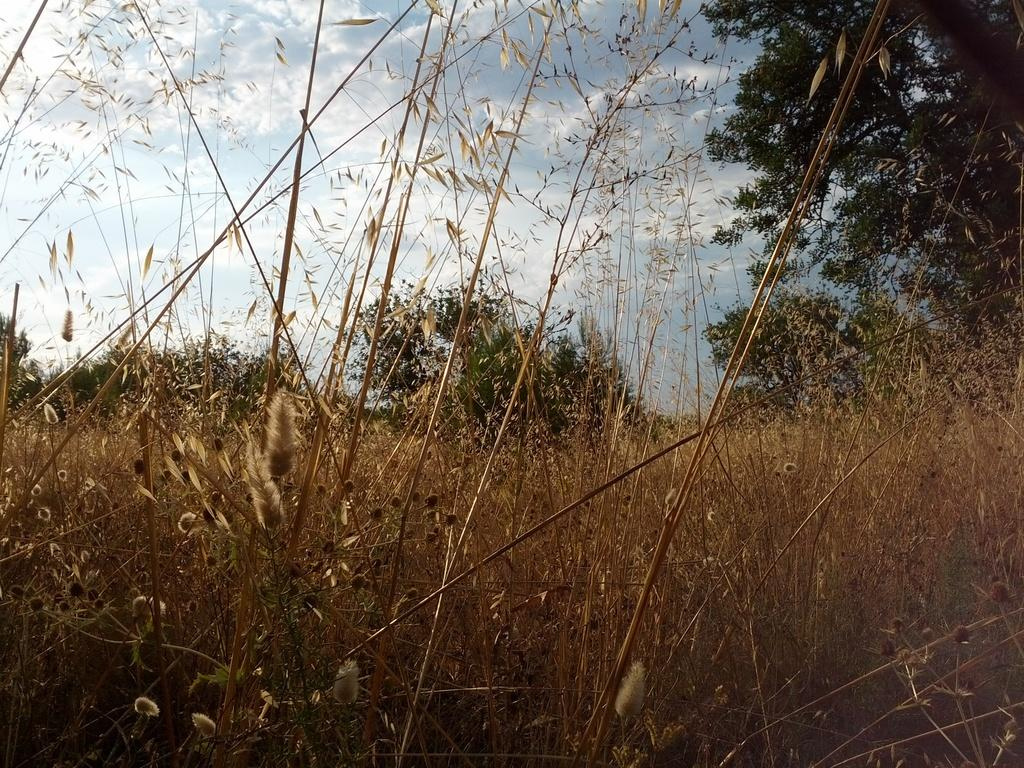What is one of the natural elements visible in the image? The sky is visible in the image. What can be seen in the sky in the image? Clouds are present in the image. What type of vegetation is visible in the image? Trees and plants are visible in the image. What is the ground covered with in the image? Grass is present in the image. What type of meat can be seen hanging from the trees in the image? There is no meat present in the image; it features the sky, clouds, trees, plants, and grass. 